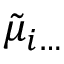<formula> <loc_0><loc_0><loc_500><loc_500>\tilde { \mu } _ { i \dots }</formula> 